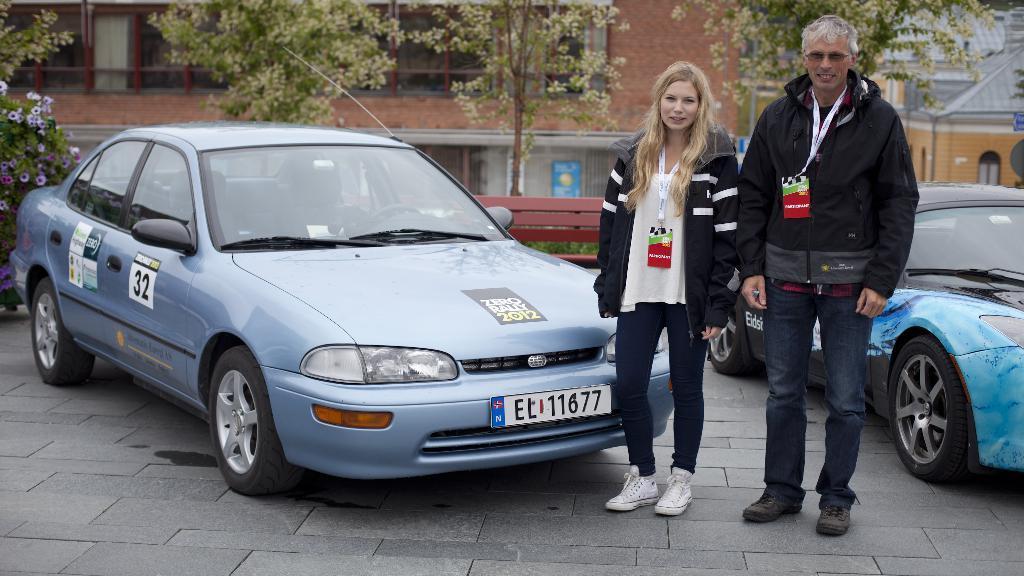Could you give a brief overview of what you see in this image? In this image I can see 2 people standing. There are 2 cars behind them. There is a bench, trees and buildings at the back. 